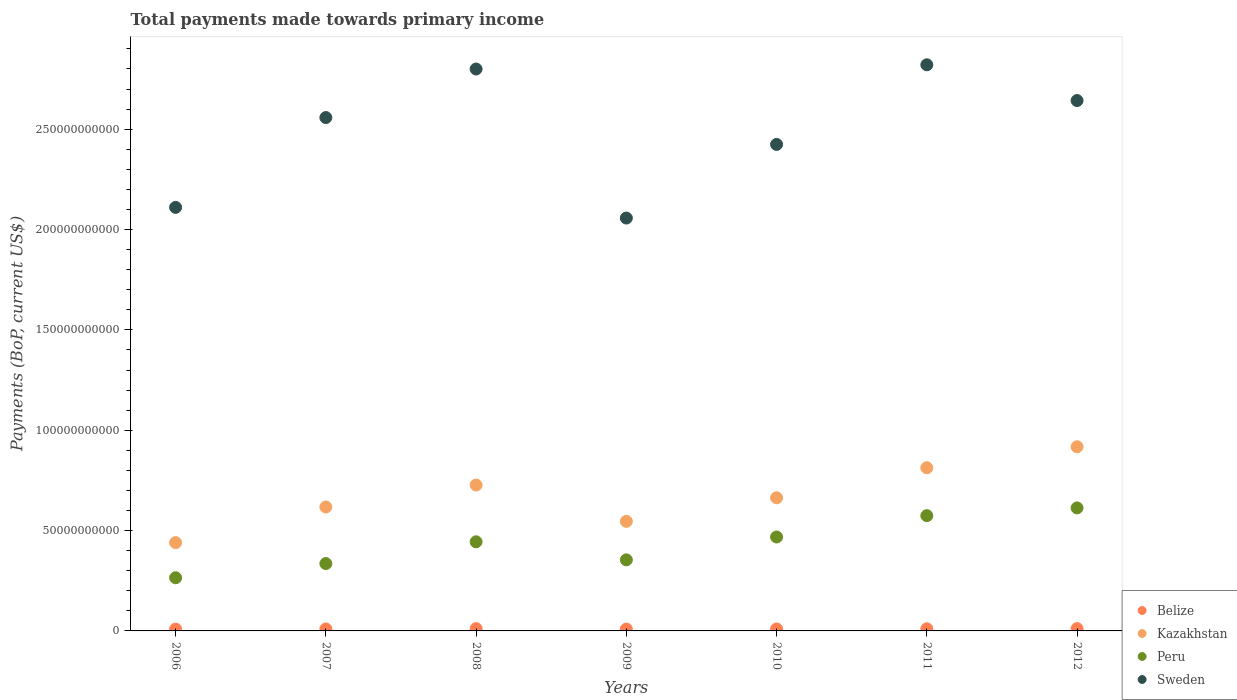Is the number of dotlines equal to the number of legend labels?
Keep it short and to the point. Yes. What is the total payments made towards primary income in Belize in 2012?
Provide a short and direct response. 1.15e+09. Across all years, what is the maximum total payments made towards primary income in Peru?
Provide a short and direct response. 6.13e+1. Across all years, what is the minimum total payments made towards primary income in Kazakhstan?
Give a very brief answer. 4.40e+1. What is the total total payments made towards primary income in Belize in the graph?
Offer a terse response. 7.05e+09. What is the difference between the total payments made towards primary income in Peru in 2008 and that in 2012?
Offer a very short reply. -1.69e+1. What is the difference between the total payments made towards primary income in Kazakhstan in 2006 and the total payments made towards primary income in Peru in 2009?
Your answer should be compact. 8.60e+09. What is the average total payments made towards primary income in Peru per year?
Your answer should be very brief. 4.36e+1. In the year 2008, what is the difference between the total payments made towards primary income in Peru and total payments made towards primary income in Belize?
Your answer should be very brief. 4.33e+1. What is the ratio of the total payments made towards primary income in Peru in 2006 to that in 2008?
Your answer should be compact. 0.6. Is the total payments made towards primary income in Kazakhstan in 2008 less than that in 2012?
Provide a succinct answer. Yes. What is the difference between the highest and the second highest total payments made towards primary income in Kazakhstan?
Make the answer very short. 1.05e+1. What is the difference between the highest and the lowest total payments made towards primary income in Peru?
Provide a short and direct response. 3.48e+1. In how many years, is the total payments made towards primary income in Sweden greater than the average total payments made towards primary income in Sweden taken over all years?
Offer a very short reply. 4. Is the sum of the total payments made towards primary income in Peru in 2010 and 2011 greater than the maximum total payments made towards primary income in Kazakhstan across all years?
Offer a terse response. Yes. How many dotlines are there?
Make the answer very short. 4. How many years are there in the graph?
Offer a very short reply. 7. What is the difference between two consecutive major ticks on the Y-axis?
Give a very brief answer. 5.00e+1. Are the values on the major ticks of Y-axis written in scientific E-notation?
Your answer should be compact. No. Where does the legend appear in the graph?
Make the answer very short. Bottom right. How many legend labels are there?
Offer a terse response. 4. How are the legend labels stacked?
Provide a succinct answer. Vertical. What is the title of the graph?
Give a very brief answer. Total payments made towards primary income. What is the label or title of the Y-axis?
Your answer should be compact. Payments (BoP, current US$). What is the Payments (BoP, current US$) of Belize in 2006?
Your answer should be compact. 8.85e+08. What is the Payments (BoP, current US$) in Kazakhstan in 2006?
Keep it short and to the point. 4.40e+1. What is the Payments (BoP, current US$) of Peru in 2006?
Give a very brief answer. 2.65e+1. What is the Payments (BoP, current US$) in Sweden in 2006?
Offer a very short reply. 2.11e+11. What is the Payments (BoP, current US$) in Belize in 2007?
Make the answer very short. 9.69e+08. What is the Payments (BoP, current US$) of Kazakhstan in 2007?
Your answer should be compact. 6.18e+1. What is the Payments (BoP, current US$) of Peru in 2007?
Give a very brief answer. 3.36e+1. What is the Payments (BoP, current US$) in Sweden in 2007?
Offer a very short reply. 2.56e+11. What is the Payments (BoP, current US$) of Belize in 2008?
Offer a terse response. 1.13e+09. What is the Payments (BoP, current US$) of Kazakhstan in 2008?
Provide a succinct answer. 7.27e+1. What is the Payments (BoP, current US$) in Peru in 2008?
Provide a succinct answer. 4.44e+1. What is the Payments (BoP, current US$) of Sweden in 2008?
Your answer should be compact. 2.80e+11. What is the Payments (BoP, current US$) of Belize in 2009?
Provide a short and direct response. 8.95e+08. What is the Payments (BoP, current US$) in Kazakhstan in 2009?
Your answer should be compact. 5.46e+1. What is the Payments (BoP, current US$) in Peru in 2009?
Your answer should be compact. 3.54e+1. What is the Payments (BoP, current US$) in Sweden in 2009?
Ensure brevity in your answer.  2.06e+11. What is the Payments (BoP, current US$) in Belize in 2010?
Your answer should be very brief. 9.72e+08. What is the Payments (BoP, current US$) in Kazakhstan in 2010?
Your response must be concise. 6.63e+1. What is the Payments (BoP, current US$) in Peru in 2010?
Your answer should be compact. 4.68e+1. What is the Payments (BoP, current US$) of Sweden in 2010?
Your answer should be very brief. 2.42e+11. What is the Payments (BoP, current US$) in Belize in 2011?
Ensure brevity in your answer.  1.05e+09. What is the Payments (BoP, current US$) of Kazakhstan in 2011?
Provide a succinct answer. 8.13e+1. What is the Payments (BoP, current US$) of Peru in 2011?
Your answer should be compact. 5.74e+1. What is the Payments (BoP, current US$) of Sweden in 2011?
Offer a very short reply. 2.82e+11. What is the Payments (BoP, current US$) of Belize in 2012?
Your answer should be compact. 1.15e+09. What is the Payments (BoP, current US$) in Kazakhstan in 2012?
Provide a short and direct response. 9.18e+1. What is the Payments (BoP, current US$) of Peru in 2012?
Your answer should be compact. 6.13e+1. What is the Payments (BoP, current US$) of Sweden in 2012?
Ensure brevity in your answer.  2.64e+11. Across all years, what is the maximum Payments (BoP, current US$) of Belize?
Your response must be concise. 1.15e+09. Across all years, what is the maximum Payments (BoP, current US$) in Kazakhstan?
Offer a very short reply. 9.18e+1. Across all years, what is the maximum Payments (BoP, current US$) in Peru?
Make the answer very short. 6.13e+1. Across all years, what is the maximum Payments (BoP, current US$) of Sweden?
Make the answer very short. 2.82e+11. Across all years, what is the minimum Payments (BoP, current US$) in Belize?
Make the answer very short. 8.85e+08. Across all years, what is the minimum Payments (BoP, current US$) of Kazakhstan?
Ensure brevity in your answer.  4.40e+1. Across all years, what is the minimum Payments (BoP, current US$) of Peru?
Offer a terse response. 2.65e+1. Across all years, what is the minimum Payments (BoP, current US$) of Sweden?
Give a very brief answer. 2.06e+11. What is the total Payments (BoP, current US$) in Belize in the graph?
Keep it short and to the point. 7.05e+09. What is the total Payments (BoP, current US$) in Kazakhstan in the graph?
Make the answer very short. 4.72e+11. What is the total Payments (BoP, current US$) in Peru in the graph?
Offer a very short reply. 3.05e+11. What is the total Payments (BoP, current US$) in Sweden in the graph?
Offer a terse response. 1.74e+12. What is the difference between the Payments (BoP, current US$) in Belize in 2006 and that in 2007?
Provide a short and direct response. -8.34e+07. What is the difference between the Payments (BoP, current US$) in Kazakhstan in 2006 and that in 2007?
Your answer should be compact. -1.77e+1. What is the difference between the Payments (BoP, current US$) of Peru in 2006 and that in 2007?
Your answer should be compact. -7.07e+09. What is the difference between the Payments (BoP, current US$) in Sweden in 2006 and that in 2007?
Provide a succinct answer. -4.48e+1. What is the difference between the Payments (BoP, current US$) of Belize in 2006 and that in 2008?
Provide a short and direct response. -2.44e+08. What is the difference between the Payments (BoP, current US$) in Kazakhstan in 2006 and that in 2008?
Provide a succinct answer. -2.87e+1. What is the difference between the Payments (BoP, current US$) of Peru in 2006 and that in 2008?
Your answer should be very brief. -1.79e+1. What is the difference between the Payments (BoP, current US$) in Sweden in 2006 and that in 2008?
Make the answer very short. -6.89e+1. What is the difference between the Payments (BoP, current US$) of Belize in 2006 and that in 2009?
Your answer should be very brief. -9.58e+06. What is the difference between the Payments (BoP, current US$) of Kazakhstan in 2006 and that in 2009?
Provide a succinct answer. -1.06e+1. What is the difference between the Payments (BoP, current US$) in Peru in 2006 and that in 2009?
Your answer should be very brief. -8.92e+09. What is the difference between the Payments (BoP, current US$) in Sweden in 2006 and that in 2009?
Keep it short and to the point. 5.31e+09. What is the difference between the Payments (BoP, current US$) in Belize in 2006 and that in 2010?
Ensure brevity in your answer.  -8.63e+07. What is the difference between the Payments (BoP, current US$) in Kazakhstan in 2006 and that in 2010?
Make the answer very short. -2.23e+1. What is the difference between the Payments (BoP, current US$) in Peru in 2006 and that in 2010?
Give a very brief answer. -2.03e+1. What is the difference between the Payments (BoP, current US$) of Sweden in 2006 and that in 2010?
Offer a terse response. -3.14e+1. What is the difference between the Payments (BoP, current US$) of Belize in 2006 and that in 2011?
Offer a very short reply. -1.67e+08. What is the difference between the Payments (BoP, current US$) of Kazakhstan in 2006 and that in 2011?
Provide a short and direct response. -3.73e+1. What is the difference between the Payments (BoP, current US$) in Peru in 2006 and that in 2011?
Your response must be concise. -3.09e+1. What is the difference between the Payments (BoP, current US$) in Sweden in 2006 and that in 2011?
Your response must be concise. -7.11e+1. What is the difference between the Payments (BoP, current US$) of Belize in 2006 and that in 2012?
Keep it short and to the point. -2.63e+08. What is the difference between the Payments (BoP, current US$) of Kazakhstan in 2006 and that in 2012?
Your answer should be very brief. -4.77e+1. What is the difference between the Payments (BoP, current US$) in Peru in 2006 and that in 2012?
Provide a succinct answer. -3.48e+1. What is the difference between the Payments (BoP, current US$) in Sweden in 2006 and that in 2012?
Ensure brevity in your answer.  -5.32e+1. What is the difference between the Payments (BoP, current US$) in Belize in 2007 and that in 2008?
Offer a very short reply. -1.60e+08. What is the difference between the Payments (BoP, current US$) of Kazakhstan in 2007 and that in 2008?
Your answer should be compact. -1.09e+1. What is the difference between the Payments (BoP, current US$) of Peru in 2007 and that in 2008?
Provide a short and direct response. -1.08e+1. What is the difference between the Payments (BoP, current US$) of Sweden in 2007 and that in 2008?
Keep it short and to the point. -2.42e+1. What is the difference between the Payments (BoP, current US$) in Belize in 2007 and that in 2009?
Keep it short and to the point. 7.38e+07. What is the difference between the Payments (BoP, current US$) in Kazakhstan in 2007 and that in 2009?
Give a very brief answer. 7.15e+09. What is the difference between the Payments (BoP, current US$) in Peru in 2007 and that in 2009?
Ensure brevity in your answer.  -1.85e+09. What is the difference between the Payments (BoP, current US$) of Sweden in 2007 and that in 2009?
Provide a short and direct response. 5.01e+1. What is the difference between the Payments (BoP, current US$) of Belize in 2007 and that in 2010?
Make the answer very short. -2.94e+06. What is the difference between the Payments (BoP, current US$) of Kazakhstan in 2007 and that in 2010?
Offer a terse response. -4.59e+09. What is the difference between the Payments (BoP, current US$) of Peru in 2007 and that in 2010?
Ensure brevity in your answer.  -1.32e+1. What is the difference between the Payments (BoP, current US$) of Sweden in 2007 and that in 2010?
Give a very brief answer. 1.34e+1. What is the difference between the Payments (BoP, current US$) of Belize in 2007 and that in 2011?
Your answer should be compact. -8.34e+07. What is the difference between the Payments (BoP, current US$) in Kazakhstan in 2007 and that in 2011?
Provide a succinct answer. -1.96e+1. What is the difference between the Payments (BoP, current US$) in Peru in 2007 and that in 2011?
Offer a terse response. -2.39e+1. What is the difference between the Payments (BoP, current US$) in Sweden in 2007 and that in 2011?
Your answer should be very brief. -2.63e+1. What is the difference between the Payments (BoP, current US$) in Belize in 2007 and that in 2012?
Keep it short and to the point. -1.80e+08. What is the difference between the Payments (BoP, current US$) of Kazakhstan in 2007 and that in 2012?
Offer a very short reply. -3.00e+1. What is the difference between the Payments (BoP, current US$) of Peru in 2007 and that in 2012?
Your answer should be very brief. -2.77e+1. What is the difference between the Payments (BoP, current US$) in Sweden in 2007 and that in 2012?
Your answer should be very brief. -8.47e+09. What is the difference between the Payments (BoP, current US$) of Belize in 2008 and that in 2009?
Make the answer very short. 2.34e+08. What is the difference between the Payments (BoP, current US$) in Kazakhstan in 2008 and that in 2009?
Give a very brief answer. 1.81e+1. What is the difference between the Payments (BoP, current US$) of Peru in 2008 and that in 2009?
Your response must be concise. 8.99e+09. What is the difference between the Payments (BoP, current US$) in Sweden in 2008 and that in 2009?
Your answer should be compact. 7.43e+1. What is the difference between the Payments (BoP, current US$) in Belize in 2008 and that in 2010?
Offer a terse response. 1.57e+08. What is the difference between the Payments (BoP, current US$) in Kazakhstan in 2008 and that in 2010?
Provide a succinct answer. 6.35e+09. What is the difference between the Payments (BoP, current US$) in Peru in 2008 and that in 2010?
Your response must be concise. -2.39e+09. What is the difference between the Payments (BoP, current US$) of Sweden in 2008 and that in 2010?
Your answer should be very brief. 3.76e+1. What is the difference between the Payments (BoP, current US$) in Belize in 2008 and that in 2011?
Give a very brief answer. 7.67e+07. What is the difference between the Payments (BoP, current US$) of Kazakhstan in 2008 and that in 2011?
Give a very brief answer. -8.61e+09. What is the difference between the Payments (BoP, current US$) in Peru in 2008 and that in 2011?
Ensure brevity in your answer.  -1.30e+1. What is the difference between the Payments (BoP, current US$) of Sweden in 2008 and that in 2011?
Provide a short and direct response. -2.11e+09. What is the difference between the Payments (BoP, current US$) in Belize in 2008 and that in 2012?
Provide a succinct answer. -1.95e+07. What is the difference between the Payments (BoP, current US$) of Kazakhstan in 2008 and that in 2012?
Offer a terse response. -1.91e+1. What is the difference between the Payments (BoP, current US$) in Peru in 2008 and that in 2012?
Keep it short and to the point. -1.69e+1. What is the difference between the Payments (BoP, current US$) in Sweden in 2008 and that in 2012?
Give a very brief answer. 1.57e+1. What is the difference between the Payments (BoP, current US$) of Belize in 2009 and that in 2010?
Provide a succinct answer. -7.67e+07. What is the difference between the Payments (BoP, current US$) of Kazakhstan in 2009 and that in 2010?
Give a very brief answer. -1.17e+1. What is the difference between the Payments (BoP, current US$) of Peru in 2009 and that in 2010?
Your answer should be compact. -1.14e+1. What is the difference between the Payments (BoP, current US$) of Sweden in 2009 and that in 2010?
Your answer should be compact. -3.67e+1. What is the difference between the Payments (BoP, current US$) of Belize in 2009 and that in 2011?
Your response must be concise. -1.57e+08. What is the difference between the Payments (BoP, current US$) in Kazakhstan in 2009 and that in 2011?
Give a very brief answer. -2.67e+1. What is the difference between the Payments (BoP, current US$) of Peru in 2009 and that in 2011?
Keep it short and to the point. -2.20e+1. What is the difference between the Payments (BoP, current US$) in Sweden in 2009 and that in 2011?
Provide a short and direct response. -7.64e+1. What is the difference between the Payments (BoP, current US$) of Belize in 2009 and that in 2012?
Provide a succinct answer. -2.53e+08. What is the difference between the Payments (BoP, current US$) of Kazakhstan in 2009 and that in 2012?
Offer a terse response. -3.72e+1. What is the difference between the Payments (BoP, current US$) of Peru in 2009 and that in 2012?
Your response must be concise. -2.59e+1. What is the difference between the Payments (BoP, current US$) of Sweden in 2009 and that in 2012?
Make the answer very short. -5.85e+1. What is the difference between the Payments (BoP, current US$) in Belize in 2010 and that in 2011?
Ensure brevity in your answer.  -8.05e+07. What is the difference between the Payments (BoP, current US$) in Kazakhstan in 2010 and that in 2011?
Your answer should be very brief. -1.50e+1. What is the difference between the Payments (BoP, current US$) in Peru in 2010 and that in 2011?
Ensure brevity in your answer.  -1.06e+1. What is the difference between the Payments (BoP, current US$) of Sweden in 2010 and that in 2011?
Provide a succinct answer. -3.97e+1. What is the difference between the Payments (BoP, current US$) of Belize in 2010 and that in 2012?
Provide a short and direct response. -1.77e+08. What is the difference between the Payments (BoP, current US$) in Kazakhstan in 2010 and that in 2012?
Provide a succinct answer. -2.54e+1. What is the difference between the Payments (BoP, current US$) of Peru in 2010 and that in 2012?
Ensure brevity in your answer.  -1.45e+1. What is the difference between the Payments (BoP, current US$) in Sweden in 2010 and that in 2012?
Your answer should be very brief. -2.19e+1. What is the difference between the Payments (BoP, current US$) of Belize in 2011 and that in 2012?
Give a very brief answer. -9.62e+07. What is the difference between the Payments (BoP, current US$) in Kazakhstan in 2011 and that in 2012?
Your answer should be compact. -1.05e+1. What is the difference between the Payments (BoP, current US$) in Peru in 2011 and that in 2012?
Your response must be concise. -3.86e+09. What is the difference between the Payments (BoP, current US$) of Sweden in 2011 and that in 2012?
Give a very brief answer. 1.78e+1. What is the difference between the Payments (BoP, current US$) of Belize in 2006 and the Payments (BoP, current US$) of Kazakhstan in 2007?
Your answer should be compact. -6.09e+1. What is the difference between the Payments (BoP, current US$) in Belize in 2006 and the Payments (BoP, current US$) in Peru in 2007?
Your response must be concise. -3.27e+1. What is the difference between the Payments (BoP, current US$) in Belize in 2006 and the Payments (BoP, current US$) in Sweden in 2007?
Offer a very short reply. -2.55e+11. What is the difference between the Payments (BoP, current US$) in Kazakhstan in 2006 and the Payments (BoP, current US$) in Peru in 2007?
Offer a terse response. 1.04e+1. What is the difference between the Payments (BoP, current US$) of Kazakhstan in 2006 and the Payments (BoP, current US$) of Sweden in 2007?
Give a very brief answer. -2.12e+11. What is the difference between the Payments (BoP, current US$) in Peru in 2006 and the Payments (BoP, current US$) in Sweden in 2007?
Give a very brief answer. -2.29e+11. What is the difference between the Payments (BoP, current US$) of Belize in 2006 and the Payments (BoP, current US$) of Kazakhstan in 2008?
Provide a short and direct response. -7.18e+1. What is the difference between the Payments (BoP, current US$) of Belize in 2006 and the Payments (BoP, current US$) of Peru in 2008?
Provide a short and direct response. -4.35e+1. What is the difference between the Payments (BoP, current US$) in Belize in 2006 and the Payments (BoP, current US$) in Sweden in 2008?
Keep it short and to the point. -2.79e+11. What is the difference between the Payments (BoP, current US$) of Kazakhstan in 2006 and the Payments (BoP, current US$) of Peru in 2008?
Your response must be concise. -3.97e+08. What is the difference between the Payments (BoP, current US$) in Kazakhstan in 2006 and the Payments (BoP, current US$) in Sweden in 2008?
Your answer should be very brief. -2.36e+11. What is the difference between the Payments (BoP, current US$) of Peru in 2006 and the Payments (BoP, current US$) of Sweden in 2008?
Offer a terse response. -2.53e+11. What is the difference between the Payments (BoP, current US$) in Belize in 2006 and the Payments (BoP, current US$) in Kazakhstan in 2009?
Ensure brevity in your answer.  -5.37e+1. What is the difference between the Payments (BoP, current US$) of Belize in 2006 and the Payments (BoP, current US$) of Peru in 2009?
Your response must be concise. -3.45e+1. What is the difference between the Payments (BoP, current US$) of Belize in 2006 and the Payments (BoP, current US$) of Sweden in 2009?
Your answer should be very brief. -2.05e+11. What is the difference between the Payments (BoP, current US$) in Kazakhstan in 2006 and the Payments (BoP, current US$) in Peru in 2009?
Provide a short and direct response. 8.60e+09. What is the difference between the Payments (BoP, current US$) in Kazakhstan in 2006 and the Payments (BoP, current US$) in Sweden in 2009?
Your response must be concise. -1.62e+11. What is the difference between the Payments (BoP, current US$) in Peru in 2006 and the Payments (BoP, current US$) in Sweden in 2009?
Provide a succinct answer. -1.79e+11. What is the difference between the Payments (BoP, current US$) in Belize in 2006 and the Payments (BoP, current US$) in Kazakhstan in 2010?
Make the answer very short. -6.55e+1. What is the difference between the Payments (BoP, current US$) in Belize in 2006 and the Payments (BoP, current US$) in Peru in 2010?
Ensure brevity in your answer.  -4.59e+1. What is the difference between the Payments (BoP, current US$) in Belize in 2006 and the Payments (BoP, current US$) in Sweden in 2010?
Make the answer very short. -2.42e+11. What is the difference between the Payments (BoP, current US$) in Kazakhstan in 2006 and the Payments (BoP, current US$) in Peru in 2010?
Give a very brief answer. -2.79e+09. What is the difference between the Payments (BoP, current US$) in Kazakhstan in 2006 and the Payments (BoP, current US$) in Sweden in 2010?
Offer a terse response. -1.98e+11. What is the difference between the Payments (BoP, current US$) in Peru in 2006 and the Payments (BoP, current US$) in Sweden in 2010?
Your response must be concise. -2.16e+11. What is the difference between the Payments (BoP, current US$) in Belize in 2006 and the Payments (BoP, current US$) in Kazakhstan in 2011?
Keep it short and to the point. -8.04e+1. What is the difference between the Payments (BoP, current US$) in Belize in 2006 and the Payments (BoP, current US$) in Peru in 2011?
Make the answer very short. -5.65e+1. What is the difference between the Payments (BoP, current US$) in Belize in 2006 and the Payments (BoP, current US$) in Sweden in 2011?
Make the answer very short. -2.81e+11. What is the difference between the Payments (BoP, current US$) in Kazakhstan in 2006 and the Payments (BoP, current US$) in Peru in 2011?
Your response must be concise. -1.34e+1. What is the difference between the Payments (BoP, current US$) in Kazakhstan in 2006 and the Payments (BoP, current US$) in Sweden in 2011?
Provide a short and direct response. -2.38e+11. What is the difference between the Payments (BoP, current US$) of Peru in 2006 and the Payments (BoP, current US$) of Sweden in 2011?
Ensure brevity in your answer.  -2.56e+11. What is the difference between the Payments (BoP, current US$) in Belize in 2006 and the Payments (BoP, current US$) in Kazakhstan in 2012?
Your answer should be compact. -9.09e+1. What is the difference between the Payments (BoP, current US$) of Belize in 2006 and the Payments (BoP, current US$) of Peru in 2012?
Give a very brief answer. -6.04e+1. What is the difference between the Payments (BoP, current US$) in Belize in 2006 and the Payments (BoP, current US$) in Sweden in 2012?
Your answer should be very brief. -2.63e+11. What is the difference between the Payments (BoP, current US$) in Kazakhstan in 2006 and the Payments (BoP, current US$) in Peru in 2012?
Ensure brevity in your answer.  -1.73e+1. What is the difference between the Payments (BoP, current US$) in Kazakhstan in 2006 and the Payments (BoP, current US$) in Sweden in 2012?
Ensure brevity in your answer.  -2.20e+11. What is the difference between the Payments (BoP, current US$) in Peru in 2006 and the Payments (BoP, current US$) in Sweden in 2012?
Ensure brevity in your answer.  -2.38e+11. What is the difference between the Payments (BoP, current US$) of Belize in 2007 and the Payments (BoP, current US$) of Kazakhstan in 2008?
Provide a succinct answer. -7.17e+1. What is the difference between the Payments (BoP, current US$) of Belize in 2007 and the Payments (BoP, current US$) of Peru in 2008?
Make the answer very short. -4.34e+1. What is the difference between the Payments (BoP, current US$) of Belize in 2007 and the Payments (BoP, current US$) of Sweden in 2008?
Make the answer very short. -2.79e+11. What is the difference between the Payments (BoP, current US$) of Kazakhstan in 2007 and the Payments (BoP, current US$) of Peru in 2008?
Your response must be concise. 1.73e+1. What is the difference between the Payments (BoP, current US$) in Kazakhstan in 2007 and the Payments (BoP, current US$) in Sweden in 2008?
Provide a succinct answer. -2.18e+11. What is the difference between the Payments (BoP, current US$) of Peru in 2007 and the Payments (BoP, current US$) of Sweden in 2008?
Your answer should be very brief. -2.46e+11. What is the difference between the Payments (BoP, current US$) in Belize in 2007 and the Payments (BoP, current US$) in Kazakhstan in 2009?
Your answer should be compact. -5.36e+1. What is the difference between the Payments (BoP, current US$) of Belize in 2007 and the Payments (BoP, current US$) of Peru in 2009?
Provide a succinct answer. -3.44e+1. What is the difference between the Payments (BoP, current US$) of Belize in 2007 and the Payments (BoP, current US$) of Sweden in 2009?
Your answer should be compact. -2.05e+11. What is the difference between the Payments (BoP, current US$) in Kazakhstan in 2007 and the Payments (BoP, current US$) in Peru in 2009?
Your answer should be very brief. 2.63e+1. What is the difference between the Payments (BoP, current US$) of Kazakhstan in 2007 and the Payments (BoP, current US$) of Sweden in 2009?
Offer a very short reply. -1.44e+11. What is the difference between the Payments (BoP, current US$) of Peru in 2007 and the Payments (BoP, current US$) of Sweden in 2009?
Offer a terse response. -1.72e+11. What is the difference between the Payments (BoP, current US$) of Belize in 2007 and the Payments (BoP, current US$) of Kazakhstan in 2010?
Your answer should be very brief. -6.54e+1. What is the difference between the Payments (BoP, current US$) in Belize in 2007 and the Payments (BoP, current US$) in Peru in 2010?
Provide a succinct answer. -4.58e+1. What is the difference between the Payments (BoP, current US$) of Belize in 2007 and the Payments (BoP, current US$) of Sweden in 2010?
Provide a succinct answer. -2.41e+11. What is the difference between the Payments (BoP, current US$) of Kazakhstan in 2007 and the Payments (BoP, current US$) of Peru in 2010?
Provide a short and direct response. 1.50e+1. What is the difference between the Payments (BoP, current US$) in Kazakhstan in 2007 and the Payments (BoP, current US$) in Sweden in 2010?
Your answer should be very brief. -1.81e+11. What is the difference between the Payments (BoP, current US$) of Peru in 2007 and the Payments (BoP, current US$) of Sweden in 2010?
Your answer should be compact. -2.09e+11. What is the difference between the Payments (BoP, current US$) in Belize in 2007 and the Payments (BoP, current US$) in Kazakhstan in 2011?
Give a very brief answer. -8.03e+1. What is the difference between the Payments (BoP, current US$) of Belize in 2007 and the Payments (BoP, current US$) of Peru in 2011?
Offer a very short reply. -5.65e+1. What is the difference between the Payments (BoP, current US$) of Belize in 2007 and the Payments (BoP, current US$) of Sweden in 2011?
Your response must be concise. -2.81e+11. What is the difference between the Payments (BoP, current US$) of Kazakhstan in 2007 and the Payments (BoP, current US$) of Peru in 2011?
Your answer should be compact. 4.32e+09. What is the difference between the Payments (BoP, current US$) of Kazakhstan in 2007 and the Payments (BoP, current US$) of Sweden in 2011?
Your response must be concise. -2.20e+11. What is the difference between the Payments (BoP, current US$) of Peru in 2007 and the Payments (BoP, current US$) of Sweden in 2011?
Your answer should be compact. -2.49e+11. What is the difference between the Payments (BoP, current US$) in Belize in 2007 and the Payments (BoP, current US$) in Kazakhstan in 2012?
Make the answer very short. -9.08e+1. What is the difference between the Payments (BoP, current US$) in Belize in 2007 and the Payments (BoP, current US$) in Peru in 2012?
Your answer should be compact. -6.03e+1. What is the difference between the Payments (BoP, current US$) in Belize in 2007 and the Payments (BoP, current US$) in Sweden in 2012?
Ensure brevity in your answer.  -2.63e+11. What is the difference between the Payments (BoP, current US$) of Kazakhstan in 2007 and the Payments (BoP, current US$) of Peru in 2012?
Your response must be concise. 4.64e+08. What is the difference between the Payments (BoP, current US$) in Kazakhstan in 2007 and the Payments (BoP, current US$) in Sweden in 2012?
Give a very brief answer. -2.03e+11. What is the difference between the Payments (BoP, current US$) in Peru in 2007 and the Payments (BoP, current US$) in Sweden in 2012?
Make the answer very short. -2.31e+11. What is the difference between the Payments (BoP, current US$) in Belize in 2008 and the Payments (BoP, current US$) in Kazakhstan in 2009?
Make the answer very short. -5.35e+1. What is the difference between the Payments (BoP, current US$) of Belize in 2008 and the Payments (BoP, current US$) of Peru in 2009?
Provide a succinct answer. -3.43e+1. What is the difference between the Payments (BoP, current US$) of Belize in 2008 and the Payments (BoP, current US$) of Sweden in 2009?
Your answer should be very brief. -2.05e+11. What is the difference between the Payments (BoP, current US$) in Kazakhstan in 2008 and the Payments (BoP, current US$) in Peru in 2009?
Make the answer very short. 3.73e+1. What is the difference between the Payments (BoP, current US$) of Kazakhstan in 2008 and the Payments (BoP, current US$) of Sweden in 2009?
Your answer should be compact. -1.33e+11. What is the difference between the Payments (BoP, current US$) of Peru in 2008 and the Payments (BoP, current US$) of Sweden in 2009?
Give a very brief answer. -1.61e+11. What is the difference between the Payments (BoP, current US$) in Belize in 2008 and the Payments (BoP, current US$) in Kazakhstan in 2010?
Offer a very short reply. -6.52e+1. What is the difference between the Payments (BoP, current US$) in Belize in 2008 and the Payments (BoP, current US$) in Peru in 2010?
Provide a succinct answer. -4.57e+1. What is the difference between the Payments (BoP, current US$) in Belize in 2008 and the Payments (BoP, current US$) in Sweden in 2010?
Offer a very short reply. -2.41e+11. What is the difference between the Payments (BoP, current US$) of Kazakhstan in 2008 and the Payments (BoP, current US$) of Peru in 2010?
Keep it short and to the point. 2.59e+1. What is the difference between the Payments (BoP, current US$) of Kazakhstan in 2008 and the Payments (BoP, current US$) of Sweden in 2010?
Make the answer very short. -1.70e+11. What is the difference between the Payments (BoP, current US$) of Peru in 2008 and the Payments (BoP, current US$) of Sweden in 2010?
Your answer should be very brief. -1.98e+11. What is the difference between the Payments (BoP, current US$) of Belize in 2008 and the Payments (BoP, current US$) of Kazakhstan in 2011?
Give a very brief answer. -8.02e+1. What is the difference between the Payments (BoP, current US$) of Belize in 2008 and the Payments (BoP, current US$) of Peru in 2011?
Provide a short and direct response. -5.63e+1. What is the difference between the Payments (BoP, current US$) in Belize in 2008 and the Payments (BoP, current US$) in Sweden in 2011?
Provide a succinct answer. -2.81e+11. What is the difference between the Payments (BoP, current US$) in Kazakhstan in 2008 and the Payments (BoP, current US$) in Peru in 2011?
Provide a short and direct response. 1.53e+1. What is the difference between the Payments (BoP, current US$) in Kazakhstan in 2008 and the Payments (BoP, current US$) in Sweden in 2011?
Give a very brief answer. -2.09e+11. What is the difference between the Payments (BoP, current US$) in Peru in 2008 and the Payments (BoP, current US$) in Sweden in 2011?
Provide a short and direct response. -2.38e+11. What is the difference between the Payments (BoP, current US$) in Belize in 2008 and the Payments (BoP, current US$) in Kazakhstan in 2012?
Offer a terse response. -9.06e+1. What is the difference between the Payments (BoP, current US$) in Belize in 2008 and the Payments (BoP, current US$) in Peru in 2012?
Offer a terse response. -6.02e+1. What is the difference between the Payments (BoP, current US$) of Belize in 2008 and the Payments (BoP, current US$) of Sweden in 2012?
Make the answer very short. -2.63e+11. What is the difference between the Payments (BoP, current US$) of Kazakhstan in 2008 and the Payments (BoP, current US$) of Peru in 2012?
Offer a terse response. 1.14e+1. What is the difference between the Payments (BoP, current US$) in Kazakhstan in 2008 and the Payments (BoP, current US$) in Sweden in 2012?
Your response must be concise. -1.92e+11. What is the difference between the Payments (BoP, current US$) of Peru in 2008 and the Payments (BoP, current US$) of Sweden in 2012?
Ensure brevity in your answer.  -2.20e+11. What is the difference between the Payments (BoP, current US$) in Belize in 2009 and the Payments (BoP, current US$) in Kazakhstan in 2010?
Your response must be concise. -6.54e+1. What is the difference between the Payments (BoP, current US$) in Belize in 2009 and the Payments (BoP, current US$) in Peru in 2010?
Make the answer very short. -4.59e+1. What is the difference between the Payments (BoP, current US$) of Belize in 2009 and the Payments (BoP, current US$) of Sweden in 2010?
Give a very brief answer. -2.42e+11. What is the difference between the Payments (BoP, current US$) in Kazakhstan in 2009 and the Payments (BoP, current US$) in Peru in 2010?
Provide a succinct answer. 7.80e+09. What is the difference between the Payments (BoP, current US$) in Kazakhstan in 2009 and the Payments (BoP, current US$) in Sweden in 2010?
Offer a very short reply. -1.88e+11. What is the difference between the Payments (BoP, current US$) of Peru in 2009 and the Payments (BoP, current US$) of Sweden in 2010?
Provide a succinct answer. -2.07e+11. What is the difference between the Payments (BoP, current US$) in Belize in 2009 and the Payments (BoP, current US$) in Kazakhstan in 2011?
Offer a terse response. -8.04e+1. What is the difference between the Payments (BoP, current US$) in Belize in 2009 and the Payments (BoP, current US$) in Peru in 2011?
Ensure brevity in your answer.  -5.65e+1. What is the difference between the Payments (BoP, current US$) of Belize in 2009 and the Payments (BoP, current US$) of Sweden in 2011?
Provide a succinct answer. -2.81e+11. What is the difference between the Payments (BoP, current US$) of Kazakhstan in 2009 and the Payments (BoP, current US$) of Peru in 2011?
Ensure brevity in your answer.  -2.83e+09. What is the difference between the Payments (BoP, current US$) in Kazakhstan in 2009 and the Payments (BoP, current US$) in Sweden in 2011?
Your answer should be very brief. -2.27e+11. What is the difference between the Payments (BoP, current US$) of Peru in 2009 and the Payments (BoP, current US$) of Sweden in 2011?
Offer a very short reply. -2.47e+11. What is the difference between the Payments (BoP, current US$) of Belize in 2009 and the Payments (BoP, current US$) of Kazakhstan in 2012?
Ensure brevity in your answer.  -9.09e+1. What is the difference between the Payments (BoP, current US$) in Belize in 2009 and the Payments (BoP, current US$) in Peru in 2012?
Offer a very short reply. -6.04e+1. What is the difference between the Payments (BoP, current US$) of Belize in 2009 and the Payments (BoP, current US$) of Sweden in 2012?
Ensure brevity in your answer.  -2.63e+11. What is the difference between the Payments (BoP, current US$) of Kazakhstan in 2009 and the Payments (BoP, current US$) of Peru in 2012?
Provide a short and direct response. -6.69e+09. What is the difference between the Payments (BoP, current US$) in Kazakhstan in 2009 and the Payments (BoP, current US$) in Sweden in 2012?
Offer a very short reply. -2.10e+11. What is the difference between the Payments (BoP, current US$) of Peru in 2009 and the Payments (BoP, current US$) of Sweden in 2012?
Offer a terse response. -2.29e+11. What is the difference between the Payments (BoP, current US$) in Belize in 2010 and the Payments (BoP, current US$) in Kazakhstan in 2011?
Offer a terse response. -8.03e+1. What is the difference between the Payments (BoP, current US$) in Belize in 2010 and the Payments (BoP, current US$) in Peru in 2011?
Your answer should be compact. -5.65e+1. What is the difference between the Payments (BoP, current US$) in Belize in 2010 and the Payments (BoP, current US$) in Sweden in 2011?
Provide a succinct answer. -2.81e+11. What is the difference between the Payments (BoP, current US$) of Kazakhstan in 2010 and the Payments (BoP, current US$) of Peru in 2011?
Provide a succinct answer. 8.91e+09. What is the difference between the Payments (BoP, current US$) in Kazakhstan in 2010 and the Payments (BoP, current US$) in Sweden in 2011?
Provide a short and direct response. -2.16e+11. What is the difference between the Payments (BoP, current US$) in Peru in 2010 and the Payments (BoP, current US$) in Sweden in 2011?
Your answer should be very brief. -2.35e+11. What is the difference between the Payments (BoP, current US$) of Belize in 2010 and the Payments (BoP, current US$) of Kazakhstan in 2012?
Your answer should be compact. -9.08e+1. What is the difference between the Payments (BoP, current US$) in Belize in 2010 and the Payments (BoP, current US$) in Peru in 2012?
Your answer should be compact. -6.03e+1. What is the difference between the Payments (BoP, current US$) of Belize in 2010 and the Payments (BoP, current US$) of Sweden in 2012?
Ensure brevity in your answer.  -2.63e+11. What is the difference between the Payments (BoP, current US$) in Kazakhstan in 2010 and the Payments (BoP, current US$) in Peru in 2012?
Your answer should be very brief. 5.05e+09. What is the difference between the Payments (BoP, current US$) in Kazakhstan in 2010 and the Payments (BoP, current US$) in Sweden in 2012?
Make the answer very short. -1.98e+11. What is the difference between the Payments (BoP, current US$) in Peru in 2010 and the Payments (BoP, current US$) in Sweden in 2012?
Ensure brevity in your answer.  -2.17e+11. What is the difference between the Payments (BoP, current US$) in Belize in 2011 and the Payments (BoP, current US$) in Kazakhstan in 2012?
Give a very brief answer. -9.07e+1. What is the difference between the Payments (BoP, current US$) of Belize in 2011 and the Payments (BoP, current US$) of Peru in 2012?
Give a very brief answer. -6.02e+1. What is the difference between the Payments (BoP, current US$) of Belize in 2011 and the Payments (BoP, current US$) of Sweden in 2012?
Your response must be concise. -2.63e+11. What is the difference between the Payments (BoP, current US$) of Kazakhstan in 2011 and the Payments (BoP, current US$) of Peru in 2012?
Your response must be concise. 2.00e+1. What is the difference between the Payments (BoP, current US$) of Kazakhstan in 2011 and the Payments (BoP, current US$) of Sweden in 2012?
Your answer should be compact. -1.83e+11. What is the difference between the Payments (BoP, current US$) of Peru in 2011 and the Payments (BoP, current US$) of Sweden in 2012?
Ensure brevity in your answer.  -2.07e+11. What is the average Payments (BoP, current US$) in Belize per year?
Make the answer very short. 1.01e+09. What is the average Payments (BoP, current US$) in Kazakhstan per year?
Provide a short and direct response. 6.75e+1. What is the average Payments (BoP, current US$) of Peru per year?
Offer a very short reply. 4.36e+1. What is the average Payments (BoP, current US$) of Sweden per year?
Offer a terse response. 2.49e+11. In the year 2006, what is the difference between the Payments (BoP, current US$) in Belize and Payments (BoP, current US$) in Kazakhstan?
Provide a succinct answer. -4.31e+1. In the year 2006, what is the difference between the Payments (BoP, current US$) of Belize and Payments (BoP, current US$) of Peru?
Keep it short and to the point. -2.56e+1. In the year 2006, what is the difference between the Payments (BoP, current US$) of Belize and Payments (BoP, current US$) of Sweden?
Ensure brevity in your answer.  -2.10e+11. In the year 2006, what is the difference between the Payments (BoP, current US$) in Kazakhstan and Payments (BoP, current US$) in Peru?
Provide a short and direct response. 1.75e+1. In the year 2006, what is the difference between the Payments (BoP, current US$) of Kazakhstan and Payments (BoP, current US$) of Sweden?
Your answer should be compact. -1.67e+11. In the year 2006, what is the difference between the Payments (BoP, current US$) in Peru and Payments (BoP, current US$) in Sweden?
Provide a short and direct response. -1.85e+11. In the year 2007, what is the difference between the Payments (BoP, current US$) in Belize and Payments (BoP, current US$) in Kazakhstan?
Provide a short and direct response. -6.08e+1. In the year 2007, what is the difference between the Payments (BoP, current US$) of Belize and Payments (BoP, current US$) of Peru?
Ensure brevity in your answer.  -3.26e+1. In the year 2007, what is the difference between the Payments (BoP, current US$) of Belize and Payments (BoP, current US$) of Sweden?
Provide a short and direct response. -2.55e+11. In the year 2007, what is the difference between the Payments (BoP, current US$) in Kazakhstan and Payments (BoP, current US$) in Peru?
Ensure brevity in your answer.  2.82e+1. In the year 2007, what is the difference between the Payments (BoP, current US$) of Kazakhstan and Payments (BoP, current US$) of Sweden?
Offer a terse response. -1.94e+11. In the year 2007, what is the difference between the Payments (BoP, current US$) in Peru and Payments (BoP, current US$) in Sweden?
Keep it short and to the point. -2.22e+11. In the year 2008, what is the difference between the Payments (BoP, current US$) of Belize and Payments (BoP, current US$) of Kazakhstan?
Your answer should be very brief. -7.16e+1. In the year 2008, what is the difference between the Payments (BoP, current US$) of Belize and Payments (BoP, current US$) of Peru?
Provide a short and direct response. -4.33e+1. In the year 2008, what is the difference between the Payments (BoP, current US$) of Belize and Payments (BoP, current US$) of Sweden?
Your answer should be compact. -2.79e+11. In the year 2008, what is the difference between the Payments (BoP, current US$) in Kazakhstan and Payments (BoP, current US$) in Peru?
Offer a terse response. 2.83e+1. In the year 2008, what is the difference between the Payments (BoP, current US$) of Kazakhstan and Payments (BoP, current US$) of Sweden?
Your answer should be very brief. -2.07e+11. In the year 2008, what is the difference between the Payments (BoP, current US$) of Peru and Payments (BoP, current US$) of Sweden?
Your answer should be very brief. -2.36e+11. In the year 2009, what is the difference between the Payments (BoP, current US$) of Belize and Payments (BoP, current US$) of Kazakhstan?
Give a very brief answer. -5.37e+1. In the year 2009, what is the difference between the Payments (BoP, current US$) of Belize and Payments (BoP, current US$) of Peru?
Your answer should be compact. -3.45e+1. In the year 2009, what is the difference between the Payments (BoP, current US$) of Belize and Payments (BoP, current US$) of Sweden?
Your answer should be very brief. -2.05e+11. In the year 2009, what is the difference between the Payments (BoP, current US$) in Kazakhstan and Payments (BoP, current US$) in Peru?
Your answer should be compact. 1.92e+1. In the year 2009, what is the difference between the Payments (BoP, current US$) in Kazakhstan and Payments (BoP, current US$) in Sweden?
Your answer should be compact. -1.51e+11. In the year 2009, what is the difference between the Payments (BoP, current US$) of Peru and Payments (BoP, current US$) of Sweden?
Keep it short and to the point. -1.70e+11. In the year 2010, what is the difference between the Payments (BoP, current US$) of Belize and Payments (BoP, current US$) of Kazakhstan?
Keep it short and to the point. -6.54e+1. In the year 2010, what is the difference between the Payments (BoP, current US$) of Belize and Payments (BoP, current US$) of Peru?
Your answer should be compact. -4.58e+1. In the year 2010, what is the difference between the Payments (BoP, current US$) in Belize and Payments (BoP, current US$) in Sweden?
Keep it short and to the point. -2.41e+11. In the year 2010, what is the difference between the Payments (BoP, current US$) in Kazakhstan and Payments (BoP, current US$) in Peru?
Offer a terse response. 1.95e+1. In the year 2010, what is the difference between the Payments (BoP, current US$) in Kazakhstan and Payments (BoP, current US$) in Sweden?
Your answer should be compact. -1.76e+11. In the year 2010, what is the difference between the Payments (BoP, current US$) in Peru and Payments (BoP, current US$) in Sweden?
Ensure brevity in your answer.  -1.96e+11. In the year 2011, what is the difference between the Payments (BoP, current US$) of Belize and Payments (BoP, current US$) of Kazakhstan?
Provide a short and direct response. -8.02e+1. In the year 2011, what is the difference between the Payments (BoP, current US$) of Belize and Payments (BoP, current US$) of Peru?
Offer a terse response. -5.64e+1. In the year 2011, what is the difference between the Payments (BoP, current US$) of Belize and Payments (BoP, current US$) of Sweden?
Your answer should be very brief. -2.81e+11. In the year 2011, what is the difference between the Payments (BoP, current US$) in Kazakhstan and Payments (BoP, current US$) in Peru?
Make the answer very short. 2.39e+1. In the year 2011, what is the difference between the Payments (BoP, current US$) in Kazakhstan and Payments (BoP, current US$) in Sweden?
Keep it short and to the point. -2.01e+11. In the year 2011, what is the difference between the Payments (BoP, current US$) in Peru and Payments (BoP, current US$) in Sweden?
Your response must be concise. -2.25e+11. In the year 2012, what is the difference between the Payments (BoP, current US$) in Belize and Payments (BoP, current US$) in Kazakhstan?
Offer a terse response. -9.06e+1. In the year 2012, what is the difference between the Payments (BoP, current US$) of Belize and Payments (BoP, current US$) of Peru?
Offer a terse response. -6.01e+1. In the year 2012, what is the difference between the Payments (BoP, current US$) of Belize and Payments (BoP, current US$) of Sweden?
Provide a succinct answer. -2.63e+11. In the year 2012, what is the difference between the Payments (BoP, current US$) of Kazakhstan and Payments (BoP, current US$) of Peru?
Your answer should be very brief. 3.05e+1. In the year 2012, what is the difference between the Payments (BoP, current US$) of Kazakhstan and Payments (BoP, current US$) of Sweden?
Make the answer very short. -1.73e+11. In the year 2012, what is the difference between the Payments (BoP, current US$) in Peru and Payments (BoP, current US$) in Sweden?
Give a very brief answer. -2.03e+11. What is the ratio of the Payments (BoP, current US$) in Belize in 2006 to that in 2007?
Provide a succinct answer. 0.91. What is the ratio of the Payments (BoP, current US$) of Kazakhstan in 2006 to that in 2007?
Give a very brief answer. 0.71. What is the ratio of the Payments (BoP, current US$) of Peru in 2006 to that in 2007?
Provide a short and direct response. 0.79. What is the ratio of the Payments (BoP, current US$) in Sweden in 2006 to that in 2007?
Provide a short and direct response. 0.82. What is the ratio of the Payments (BoP, current US$) in Belize in 2006 to that in 2008?
Your answer should be very brief. 0.78. What is the ratio of the Payments (BoP, current US$) of Kazakhstan in 2006 to that in 2008?
Keep it short and to the point. 0.61. What is the ratio of the Payments (BoP, current US$) of Peru in 2006 to that in 2008?
Ensure brevity in your answer.  0.6. What is the ratio of the Payments (BoP, current US$) of Sweden in 2006 to that in 2008?
Give a very brief answer. 0.75. What is the ratio of the Payments (BoP, current US$) of Belize in 2006 to that in 2009?
Ensure brevity in your answer.  0.99. What is the ratio of the Payments (BoP, current US$) of Kazakhstan in 2006 to that in 2009?
Your answer should be very brief. 0.81. What is the ratio of the Payments (BoP, current US$) in Peru in 2006 to that in 2009?
Your answer should be very brief. 0.75. What is the ratio of the Payments (BoP, current US$) in Sweden in 2006 to that in 2009?
Your answer should be compact. 1.03. What is the ratio of the Payments (BoP, current US$) in Belize in 2006 to that in 2010?
Keep it short and to the point. 0.91. What is the ratio of the Payments (BoP, current US$) of Kazakhstan in 2006 to that in 2010?
Your answer should be compact. 0.66. What is the ratio of the Payments (BoP, current US$) in Peru in 2006 to that in 2010?
Offer a terse response. 0.57. What is the ratio of the Payments (BoP, current US$) of Sweden in 2006 to that in 2010?
Give a very brief answer. 0.87. What is the ratio of the Payments (BoP, current US$) in Belize in 2006 to that in 2011?
Make the answer very short. 0.84. What is the ratio of the Payments (BoP, current US$) of Kazakhstan in 2006 to that in 2011?
Give a very brief answer. 0.54. What is the ratio of the Payments (BoP, current US$) in Peru in 2006 to that in 2011?
Offer a terse response. 0.46. What is the ratio of the Payments (BoP, current US$) of Sweden in 2006 to that in 2011?
Provide a succinct answer. 0.75. What is the ratio of the Payments (BoP, current US$) in Belize in 2006 to that in 2012?
Make the answer very short. 0.77. What is the ratio of the Payments (BoP, current US$) in Kazakhstan in 2006 to that in 2012?
Your answer should be compact. 0.48. What is the ratio of the Payments (BoP, current US$) in Peru in 2006 to that in 2012?
Ensure brevity in your answer.  0.43. What is the ratio of the Payments (BoP, current US$) of Sweden in 2006 to that in 2012?
Make the answer very short. 0.8. What is the ratio of the Payments (BoP, current US$) in Belize in 2007 to that in 2008?
Provide a short and direct response. 0.86. What is the ratio of the Payments (BoP, current US$) in Kazakhstan in 2007 to that in 2008?
Provide a short and direct response. 0.85. What is the ratio of the Payments (BoP, current US$) in Peru in 2007 to that in 2008?
Offer a terse response. 0.76. What is the ratio of the Payments (BoP, current US$) of Sweden in 2007 to that in 2008?
Your answer should be compact. 0.91. What is the ratio of the Payments (BoP, current US$) of Belize in 2007 to that in 2009?
Your response must be concise. 1.08. What is the ratio of the Payments (BoP, current US$) in Kazakhstan in 2007 to that in 2009?
Keep it short and to the point. 1.13. What is the ratio of the Payments (BoP, current US$) of Peru in 2007 to that in 2009?
Make the answer very short. 0.95. What is the ratio of the Payments (BoP, current US$) in Sweden in 2007 to that in 2009?
Provide a succinct answer. 1.24. What is the ratio of the Payments (BoP, current US$) of Kazakhstan in 2007 to that in 2010?
Provide a succinct answer. 0.93. What is the ratio of the Payments (BoP, current US$) in Peru in 2007 to that in 2010?
Your answer should be very brief. 0.72. What is the ratio of the Payments (BoP, current US$) of Sweden in 2007 to that in 2010?
Make the answer very short. 1.06. What is the ratio of the Payments (BoP, current US$) in Belize in 2007 to that in 2011?
Your answer should be compact. 0.92. What is the ratio of the Payments (BoP, current US$) of Kazakhstan in 2007 to that in 2011?
Keep it short and to the point. 0.76. What is the ratio of the Payments (BoP, current US$) of Peru in 2007 to that in 2011?
Offer a very short reply. 0.58. What is the ratio of the Payments (BoP, current US$) of Sweden in 2007 to that in 2011?
Keep it short and to the point. 0.91. What is the ratio of the Payments (BoP, current US$) in Belize in 2007 to that in 2012?
Offer a very short reply. 0.84. What is the ratio of the Payments (BoP, current US$) of Kazakhstan in 2007 to that in 2012?
Provide a succinct answer. 0.67. What is the ratio of the Payments (BoP, current US$) of Peru in 2007 to that in 2012?
Make the answer very short. 0.55. What is the ratio of the Payments (BoP, current US$) in Sweden in 2007 to that in 2012?
Make the answer very short. 0.97. What is the ratio of the Payments (BoP, current US$) in Belize in 2008 to that in 2009?
Keep it short and to the point. 1.26. What is the ratio of the Payments (BoP, current US$) of Kazakhstan in 2008 to that in 2009?
Give a very brief answer. 1.33. What is the ratio of the Payments (BoP, current US$) of Peru in 2008 to that in 2009?
Offer a very short reply. 1.25. What is the ratio of the Payments (BoP, current US$) in Sweden in 2008 to that in 2009?
Offer a terse response. 1.36. What is the ratio of the Payments (BoP, current US$) in Belize in 2008 to that in 2010?
Your answer should be very brief. 1.16. What is the ratio of the Payments (BoP, current US$) in Kazakhstan in 2008 to that in 2010?
Provide a succinct answer. 1.1. What is the ratio of the Payments (BoP, current US$) in Peru in 2008 to that in 2010?
Make the answer very short. 0.95. What is the ratio of the Payments (BoP, current US$) of Sweden in 2008 to that in 2010?
Provide a short and direct response. 1.16. What is the ratio of the Payments (BoP, current US$) of Belize in 2008 to that in 2011?
Offer a very short reply. 1.07. What is the ratio of the Payments (BoP, current US$) in Kazakhstan in 2008 to that in 2011?
Offer a terse response. 0.89. What is the ratio of the Payments (BoP, current US$) of Peru in 2008 to that in 2011?
Offer a very short reply. 0.77. What is the ratio of the Payments (BoP, current US$) of Kazakhstan in 2008 to that in 2012?
Your answer should be very brief. 0.79. What is the ratio of the Payments (BoP, current US$) of Peru in 2008 to that in 2012?
Provide a succinct answer. 0.72. What is the ratio of the Payments (BoP, current US$) in Sweden in 2008 to that in 2012?
Your response must be concise. 1.06. What is the ratio of the Payments (BoP, current US$) in Belize in 2009 to that in 2010?
Your answer should be very brief. 0.92. What is the ratio of the Payments (BoP, current US$) of Kazakhstan in 2009 to that in 2010?
Ensure brevity in your answer.  0.82. What is the ratio of the Payments (BoP, current US$) in Peru in 2009 to that in 2010?
Offer a very short reply. 0.76. What is the ratio of the Payments (BoP, current US$) of Sweden in 2009 to that in 2010?
Your answer should be compact. 0.85. What is the ratio of the Payments (BoP, current US$) of Belize in 2009 to that in 2011?
Keep it short and to the point. 0.85. What is the ratio of the Payments (BoP, current US$) of Kazakhstan in 2009 to that in 2011?
Provide a short and direct response. 0.67. What is the ratio of the Payments (BoP, current US$) in Peru in 2009 to that in 2011?
Give a very brief answer. 0.62. What is the ratio of the Payments (BoP, current US$) in Sweden in 2009 to that in 2011?
Offer a terse response. 0.73. What is the ratio of the Payments (BoP, current US$) in Belize in 2009 to that in 2012?
Your response must be concise. 0.78. What is the ratio of the Payments (BoP, current US$) of Kazakhstan in 2009 to that in 2012?
Provide a succinct answer. 0.59. What is the ratio of the Payments (BoP, current US$) in Peru in 2009 to that in 2012?
Your answer should be very brief. 0.58. What is the ratio of the Payments (BoP, current US$) in Sweden in 2009 to that in 2012?
Provide a succinct answer. 0.78. What is the ratio of the Payments (BoP, current US$) of Belize in 2010 to that in 2011?
Make the answer very short. 0.92. What is the ratio of the Payments (BoP, current US$) in Kazakhstan in 2010 to that in 2011?
Your answer should be compact. 0.82. What is the ratio of the Payments (BoP, current US$) of Peru in 2010 to that in 2011?
Provide a succinct answer. 0.81. What is the ratio of the Payments (BoP, current US$) of Sweden in 2010 to that in 2011?
Offer a terse response. 0.86. What is the ratio of the Payments (BoP, current US$) in Belize in 2010 to that in 2012?
Offer a very short reply. 0.85. What is the ratio of the Payments (BoP, current US$) in Kazakhstan in 2010 to that in 2012?
Your response must be concise. 0.72. What is the ratio of the Payments (BoP, current US$) of Peru in 2010 to that in 2012?
Your response must be concise. 0.76. What is the ratio of the Payments (BoP, current US$) in Sweden in 2010 to that in 2012?
Give a very brief answer. 0.92. What is the ratio of the Payments (BoP, current US$) in Belize in 2011 to that in 2012?
Provide a short and direct response. 0.92. What is the ratio of the Payments (BoP, current US$) of Kazakhstan in 2011 to that in 2012?
Give a very brief answer. 0.89. What is the ratio of the Payments (BoP, current US$) in Peru in 2011 to that in 2012?
Provide a short and direct response. 0.94. What is the ratio of the Payments (BoP, current US$) in Sweden in 2011 to that in 2012?
Ensure brevity in your answer.  1.07. What is the difference between the highest and the second highest Payments (BoP, current US$) in Belize?
Offer a terse response. 1.95e+07. What is the difference between the highest and the second highest Payments (BoP, current US$) in Kazakhstan?
Your response must be concise. 1.05e+1. What is the difference between the highest and the second highest Payments (BoP, current US$) of Peru?
Give a very brief answer. 3.86e+09. What is the difference between the highest and the second highest Payments (BoP, current US$) in Sweden?
Give a very brief answer. 2.11e+09. What is the difference between the highest and the lowest Payments (BoP, current US$) in Belize?
Provide a succinct answer. 2.63e+08. What is the difference between the highest and the lowest Payments (BoP, current US$) of Kazakhstan?
Give a very brief answer. 4.77e+1. What is the difference between the highest and the lowest Payments (BoP, current US$) in Peru?
Make the answer very short. 3.48e+1. What is the difference between the highest and the lowest Payments (BoP, current US$) in Sweden?
Give a very brief answer. 7.64e+1. 